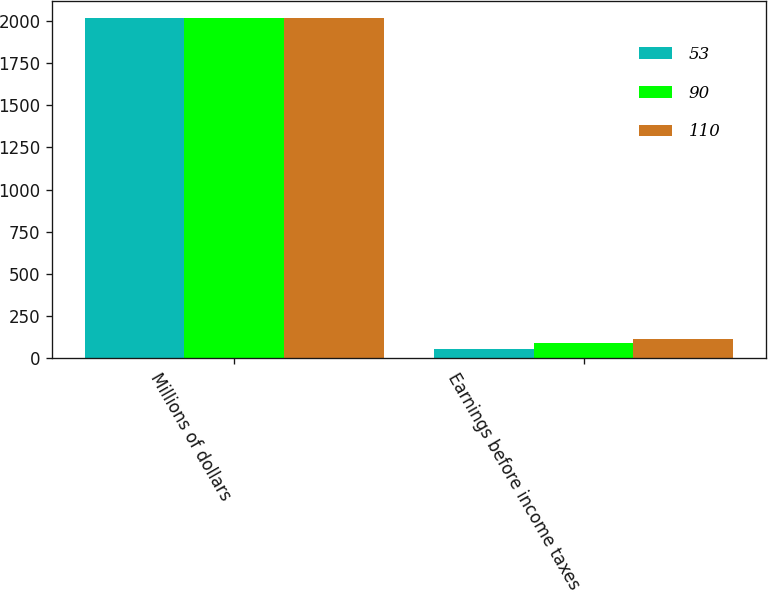Convert chart. <chart><loc_0><loc_0><loc_500><loc_500><stacked_bar_chart><ecel><fcel>Millions of dollars<fcel>Earnings before income taxes<nl><fcel>53<fcel>2018<fcel>53<nl><fcel>90<fcel>2017<fcel>90<nl><fcel>110<fcel>2016<fcel>110<nl></chart> 